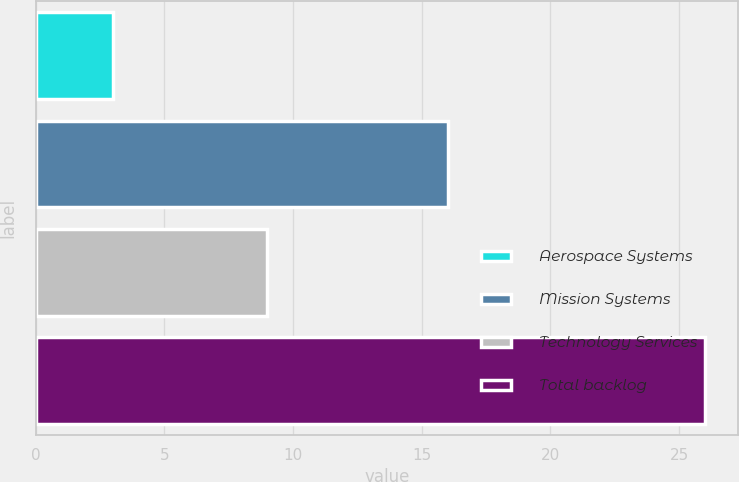<chart> <loc_0><loc_0><loc_500><loc_500><bar_chart><fcel>Aerospace Systems<fcel>Mission Systems<fcel>Technology Services<fcel>Total backlog<nl><fcel>3<fcel>16<fcel>9<fcel>26<nl></chart> 